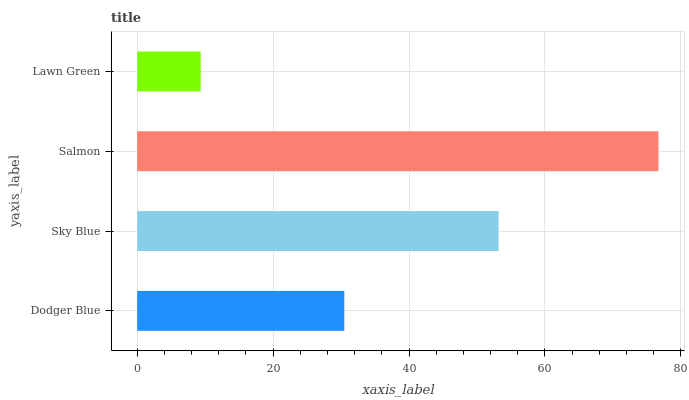Is Lawn Green the minimum?
Answer yes or no. Yes. Is Salmon the maximum?
Answer yes or no. Yes. Is Sky Blue the minimum?
Answer yes or no. No. Is Sky Blue the maximum?
Answer yes or no. No. Is Sky Blue greater than Dodger Blue?
Answer yes or no. Yes. Is Dodger Blue less than Sky Blue?
Answer yes or no. Yes. Is Dodger Blue greater than Sky Blue?
Answer yes or no. No. Is Sky Blue less than Dodger Blue?
Answer yes or no. No. Is Sky Blue the high median?
Answer yes or no. Yes. Is Dodger Blue the low median?
Answer yes or no. Yes. Is Dodger Blue the high median?
Answer yes or no. No. Is Lawn Green the low median?
Answer yes or no. No. 